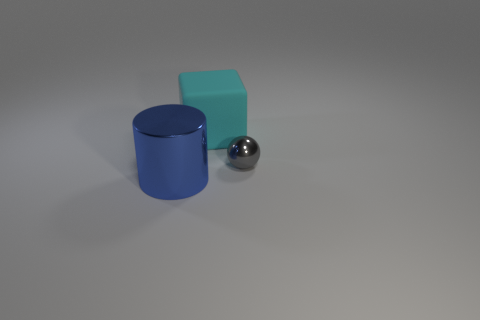Add 3 large cyan cubes. How many objects exist? 6 Subtract all spheres. How many objects are left? 2 Subtract all spheres. Subtract all gray metallic objects. How many objects are left? 1 Add 1 cyan matte things. How many cyan matte things are left? 2 Add 3 purple matte things. How many purple matte things exist? 3 Subtract 0 yellow cylinders. How many objects are left? 3 